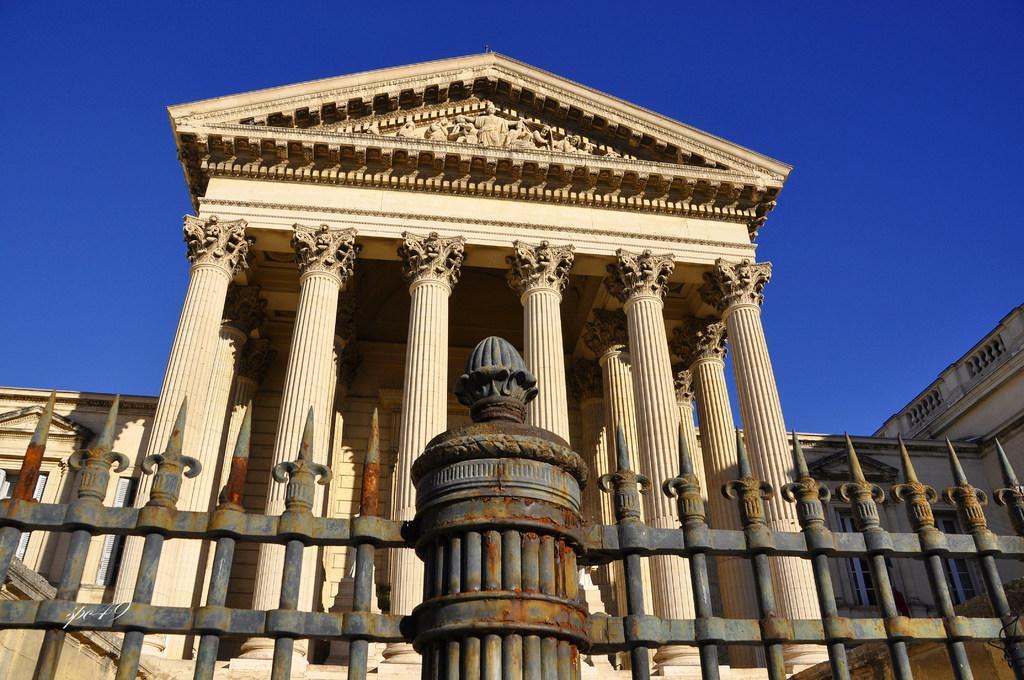Please provide a concise description of this image. Here we can see pillars,fence and wall. Top of the image we can see statues and we can see sky. 